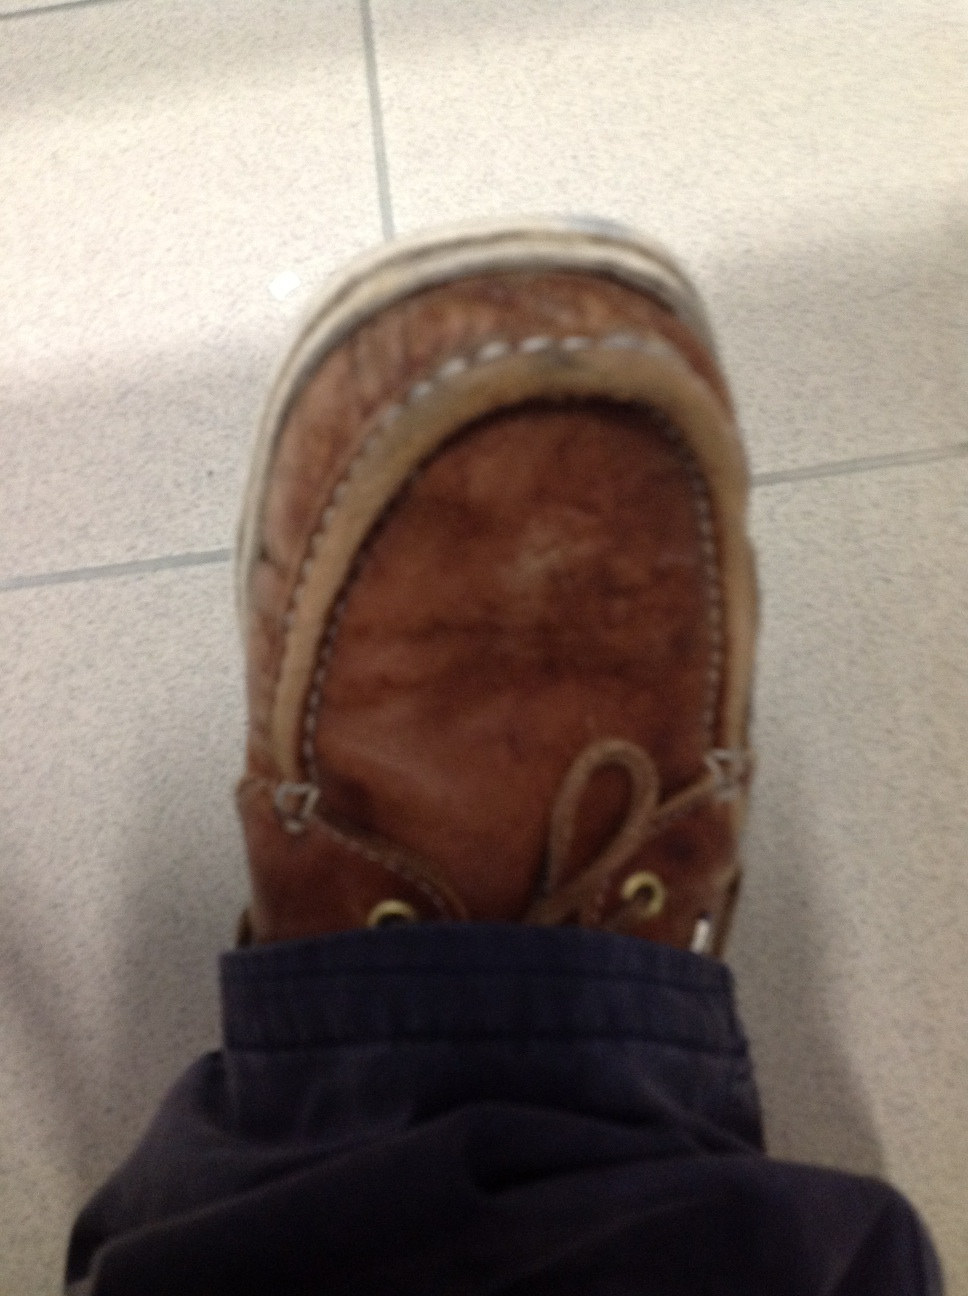Can you create a story about the owner of this shoe? Once upon a time, there was a professor named John who loved his brown leather loafers. John had worn these shoes on many adventures - from exploring ancient libraries to giving lectures at prestigious universities. The creases and worn leather represented years of dedication and passion for knowledge. These loafers had seen the steps of wisdom and the paths of discovery, becoming a symbol of John's relentless pursuit of enlightenment. 